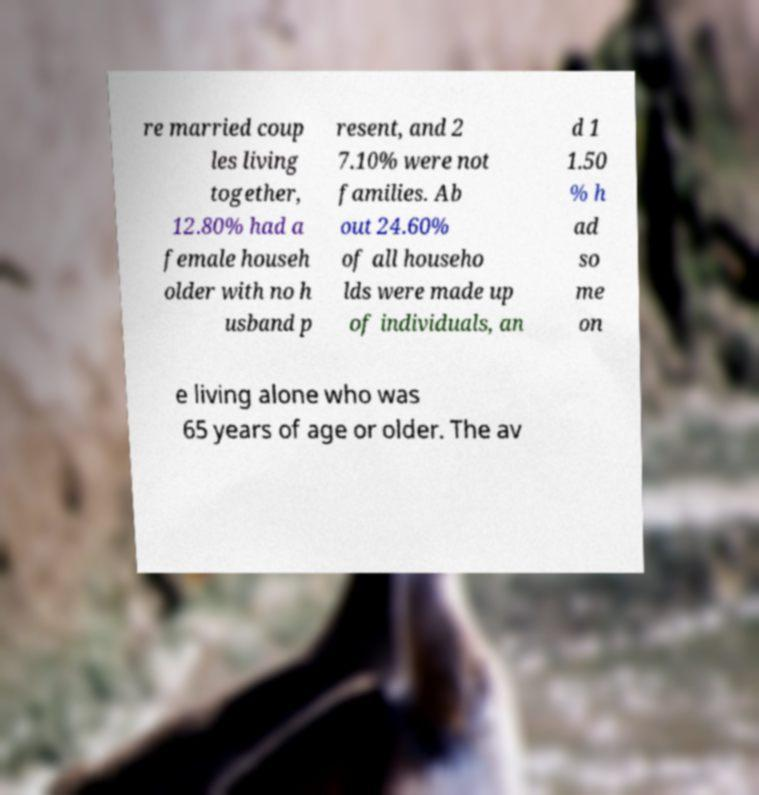I need the written content from this picture converted into text. Can you do that? re married coup les living together, 12.80% had a female househ older with no h usband p resent, and 2 7.10% were not families. Ab out 24.60% of all househo lds were made up of individuals, an d 1 1.50 % h ad so me on e living alone who was 65 years of age or older. The av 